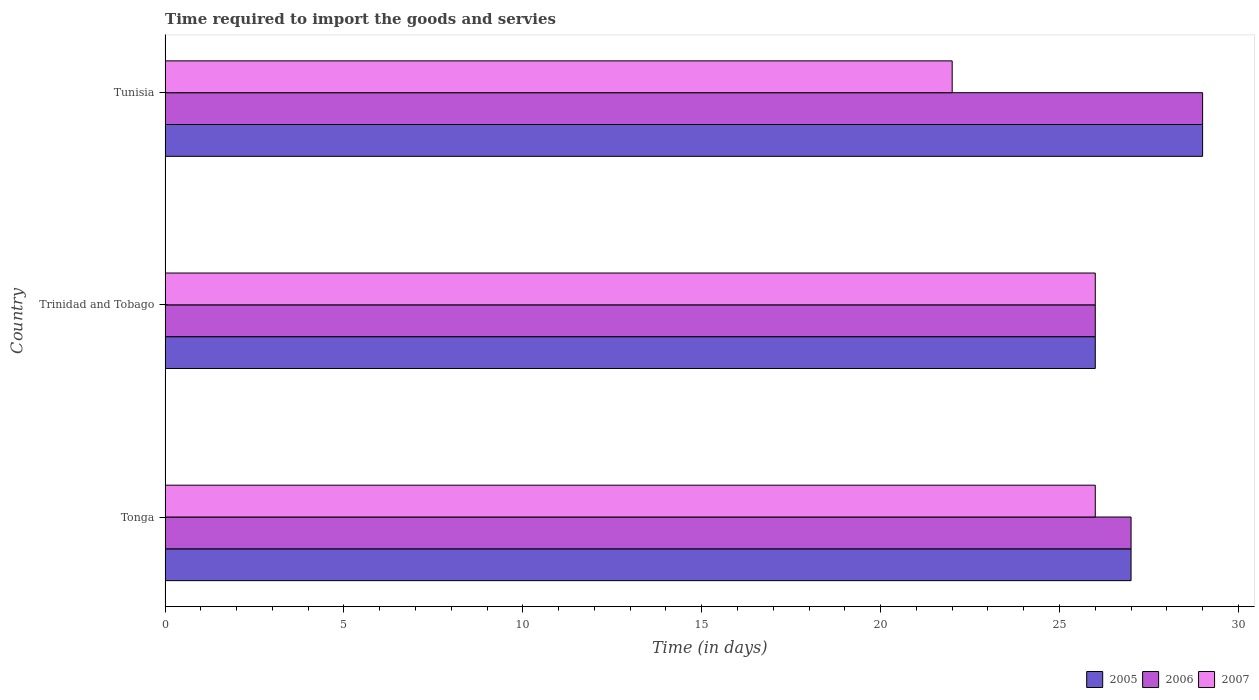How many different coloured bars are there?
Offer a terse response. 3. How many groups of bars are there?
Ensure brevity in your answer.  3. Are the number of bars per tick equal to the number of legend labels?
Offer a terse response. Yes. Are the number of bars on each tick of the Y-axis equal?
Your response must be concise. Yes. How many bars are there on the 2nd tick from the top?
Your response must be concise. 3. How many bars are there on the 2nd tick from the bottom?
Keep it short and to the point. 3. What is the label of the 2nd group of bars from the top?
Make the answer very short. Trinidad and Tobago. In how many cases, is the number of bars for a given country not equal to the number of legend labels?
Your answer should be compact. 0. Across all countries, what is the maximum number of days required to import the goods and services in 2006?
Ensure brevity in your answer.  29. Across all countries, what is the minimum number of days required to import the goods and services in 2005?
Keep it short and to the point. 26. In which country was the number of days required to import the goods and services in 2007 maximum?
Ensure brevity in your answer.  Tonga. In which country was the number of days required to import the goods and services in 2006 minimum?
Offer a terse response. Trinidad and Tobago. What is the average number of days required to import the goods and services in 2005 per country?
Provide a short and direct response. 27.33. In how many countries, is the number of days required to import the goods and services in 2005 greater than 21 days?
Make the answer very short. 3. What is the ratio of the number of days required to import the goods and services in 2006 in Tonga to that in Tunisia?
Your response must be concise. 0.93. Is the number of days required to import the goods and services in 2007 in Tonga less than that in Trinidad and Tobago?
Your answer should be very brief. No. What is the difference between the highest and the lowest number of days required to import the goods and services in 2007?
Ensure brevity in your answer.  4. How many bars are there?
Provide a succinct answer. 9. Are all the bars in the graph horizontal?
Provide a short and direct response. Yes. What is the difference between two consecutive major ticks on the X-axis?
Keep it short and to the point. 5. Are the values on the major ticks of X-axis written in scientific E-notation?
Provide a short and direct response. No. Does the graph contain any zero values?
Your answer should be compact. No. Does the graph contain grids?
Keep it short and to the point. No. Where does the legend appear in the graph?
Keep it short and to the point. Bottom right. How many legend labels are there?
Your response must be concise. 3. How are the legend labels stacked?
Give a very brief answer. Horizontal. What is the title of the graph?
Provide a short and direct response. Time required to import the goods and servies. What is the label or title of the X-axis?
Provide a succinct answer. Time (in days). What is the Time (in days) of 2005 in Tonga?
Provide a short and direct response. 27. What is the Time (in days) in 2006 in Tonga?
Your answer should be compact. 27. What is the Time (in days) of 2007 in Tonga?
Ensure brevity in your answer.  26. What is the Time (in days) in 2005 in Trinidad and Tobago?
Your answer should be very brief. 26. What is the Time (in days) in 2006 in Trinidad and Tobago?
Provide a succinct answer. 26. What is the Time (in days) in 2005 in Tunisia?
Make the answer very short. 29. What is the Time (in days) in 2006 in Tunisia?
Ensure brevity in your answer.  29. Across all countries, what is the maximum Time (in days) in 2005?
Offer a terse response. 29. Across all countries, what is the maximum Time (in days) of 2007?
Provide a short and direct response. 26. Across all countries, what is the minimum Time (in days) in 2007?
Make the answer very short. 22. What is the total Time (in days) in 2005 in the graph?
Your answer should be very brief. 82. What is the difference between the Time (in days) in 2006 in Tonga and that in Trinidad and Tobago?
Your answer should be compact. 1. What is the difference between the Time (in days) in 2007 in Tonga and that in Trinidad and Tobago?
Give a very brief answer. 0. What is the difference between the Time (in days) of 2006 in Tonga and that in Tunisia?
Make the answer very short. -2. What is the difference between the Time (in days) of 2005 in Trinidad and Tobago and that in Tunisia?
Offer a terse response. -3. What is the difference between the Time (in days) in 2006 in Trinidad and Tobago and that in Tunisia?
Ensure brevity in your answer.  -3. What is the difference between the Time (in days) of 2007 in Trinidad and Tobago and that in Tunisia?
Offer a terse response. 4. What is the difference between the Time (in days) of 2005 in Tonga and the Time (in days) of 2006 in Trinidad and Tobago?
Offer a very short reply. 1. What is the difference between the Time (in days) in 2006 in Tonga and the Time (in days) in 2007 in Trinidad and Tobago?
Your answer should be compact. 1. What is the difference between the Time (in days) in 2005 in Tonga and the Time (in days) in 2006 in Tunisia?
Make the answer very short. -2. What is the difference between the Time (in days) of 2005 in Tonga and the Time (in days) of 2007 in Tunisia?
Your response must be concise. 5. What is the difference between the Time (in days) of 2006 in Trinidad and Tobago and the Time (in days) of 2007 in Tunisia?
Provide a succinct answer. 4. What is the average Time (in days) in 2005 per country?
Give a very brief answer. 27.33. What is the average Time (in days) in 2006 per country?
Give a very brief answer. 27.33. What is the average Time (in days) of 2007 per country?
Keep it short and to the point. 24.67. What is the difference between the Time (in days) in 2005 and Time (in days) in 2007 in Tonga?
Provide a succinct answer. 1. What is the difference between the Time (in days) in 2006 and Time (in days) in 2007 in Tonga?
Make the answer very short. 1. What is the difference between the Time (in days) of 2005 and Time (in days) of 2007 in Trinidad and Tobago?
Provide a succinct answer. 0. What is the difference between the Time (in days) in 2006 and Time (in days) in 2007 in Trinidad and Tobago?
Provide a succinct answer. 0. What is the difference between the Time (in days) in 2006 and Time (in days) in 2007 in Tunisia?
Your answer should be very brief. 7. What is the ratio of the Time (in days) in 2006 in Tonga to that in Trinidad and Tobago?
Your answer should be very brief. 1.04. What is the ratio of the Time (in days) in 2007 in Tonga to that in Trinidad and Tobago?
Provide a short and direct response. 1. What is the ratio of the Time (in days) of 2006 in Tonga to that in Tunisia?
Your answer should be very brief. 0.93. What is the ratio of the Time (in days) in 2007 in Tonga to that in Tunisia?
Ensure brevity in your answer.  1.18. What is the ratio of the Time (in days) in 2005 in Trinidad and Tobago to that in Tunisia?
Offer a very short reply. 0.9. What is the ratio of the Time (in days) in 2006 in Trinidad and Tobago to that in Tunisia?
Provide a succinct answer. 0.9. What is the ratio of the Time (in days) of 2007 in Trinidad and Tobago to that in Tunisia?
Keep it short and to the point. 1.18. What is the difference between the highest and the second highest Time (in days) in 2005?
Provide a short and direct response. 2. What is the difference between the highest and the lowest Time (in days) of 2005?
Make the answer very short. 3. What is the difference between the highest and the lowest Time (in days) of 2006?
Offer a terse response. 3. What is the difference between the highest and the lowest Time (in days) of 2007?
Give a very brief answer. 4. 